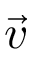Convert formula to latex. <formula><loc_0><loc_0><loc_500><loc_500>\vec { v }</formula> 